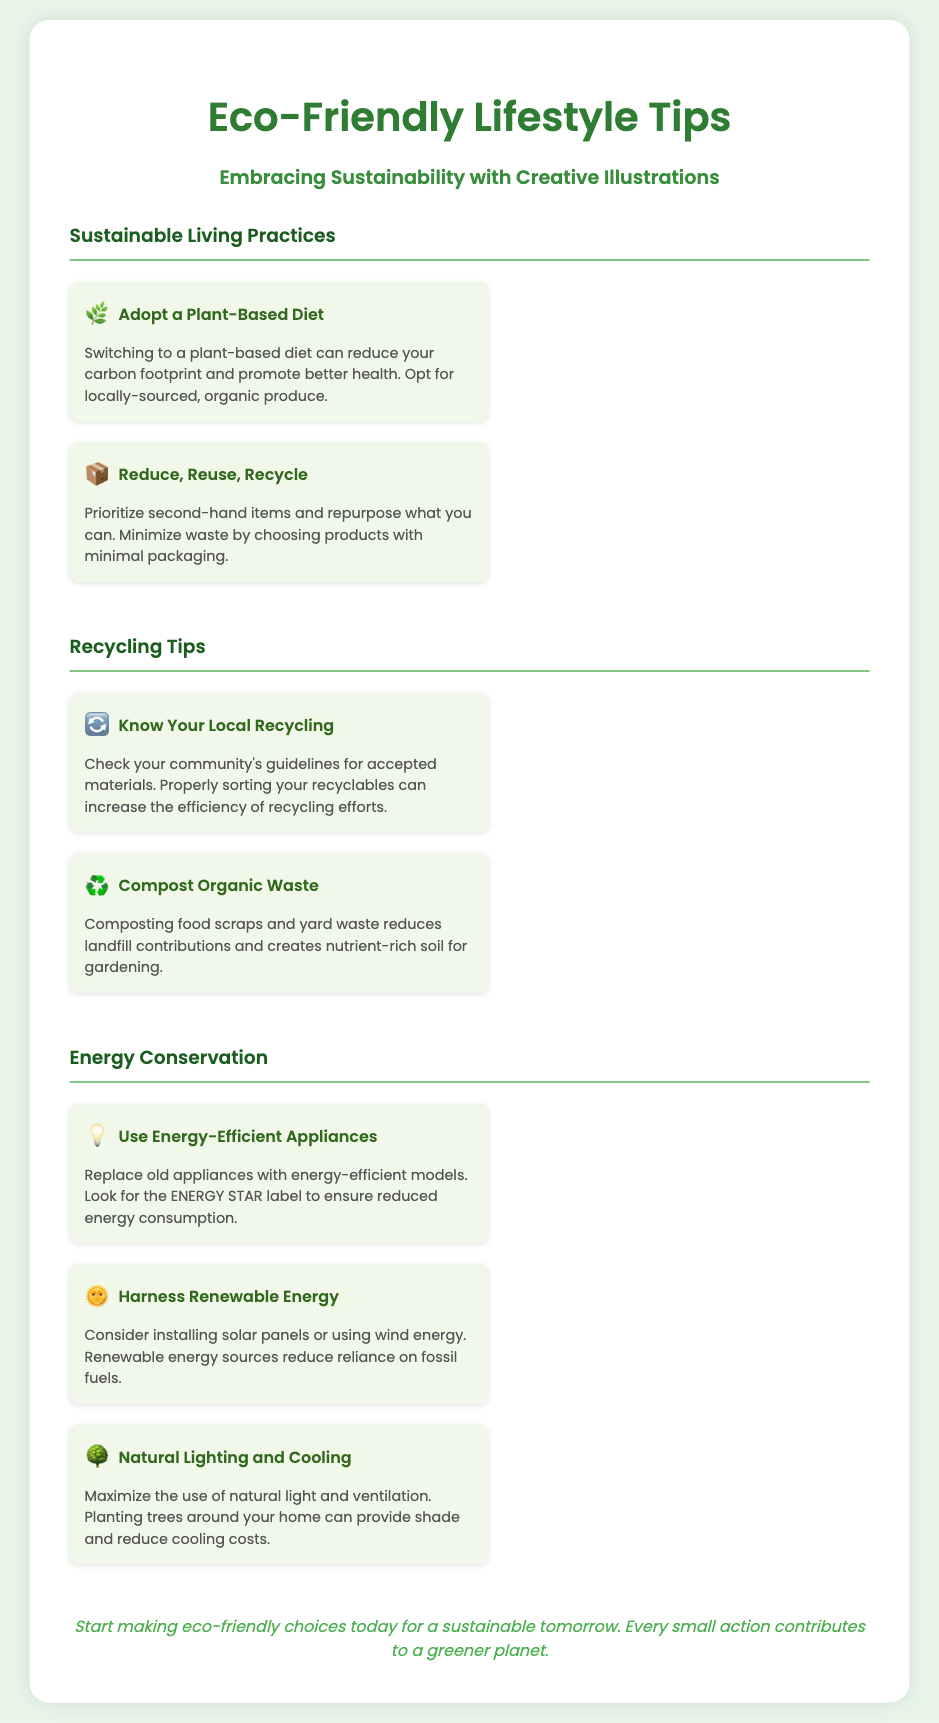What is the main title of the poster? The main title is prominently displayed at the top of the poster.
Answer: Eco-Friendly Lifestyle Tips What icon represents "Adopt a Plant-Based Diet"? Each tip is accompanied by a unique icon; this one specifically features a plant.
Answer: 🌿 What is one key benefit of composting organic waste? The document mentions a specific advantage of composting in the item details.
Answer: Reduces landfill contributions How many sections are there in the poster? The poster includes several different topics, each marked as a section.
Answer: Three What color is used for the heading of the "Recycling Tips" section? Each section heading features a distinct color for visual appeal.
Answer: #1b5e20 What energy-efficient feature should one look for when replacing appliances? The document provides specific guidance for choosing new appliances to conserve energy.
Answer: ENERGY STAR label Which energy conservation method involves using sunlight? The poster describes methods that leverage natural resources for energy savings.
Answer: Harness Renewable Energy What does the footer encourage readers to do? The closing message of the poster emphasizes a particular call to action.
Answer: Make eco-friendly choices 